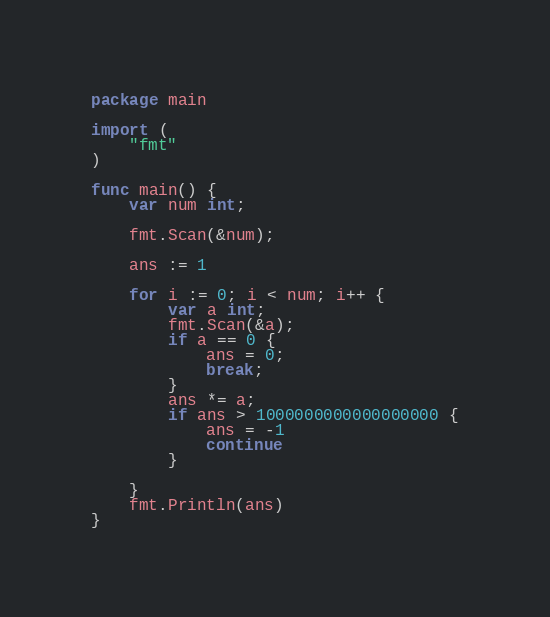Convert code to text. <code><loc_0><loc_0><loc_500><loc_500><_Go_>package main

import (
	"fmt"
)

func main() {
    var num int;
    
    fmt.Scan(&num);
    
    ans := 1
    
    for i := 0; i < num; i++ {
        var a int;
        fmt.Scan(&a);
        if a == 0 {
            ans = 0;
            break;
        }
        ans *= a;
        if ans > 1000000000000000000 {
            ans = -1
            continue
        }
        
    }
    fmt.Println(ans)
}</code> 